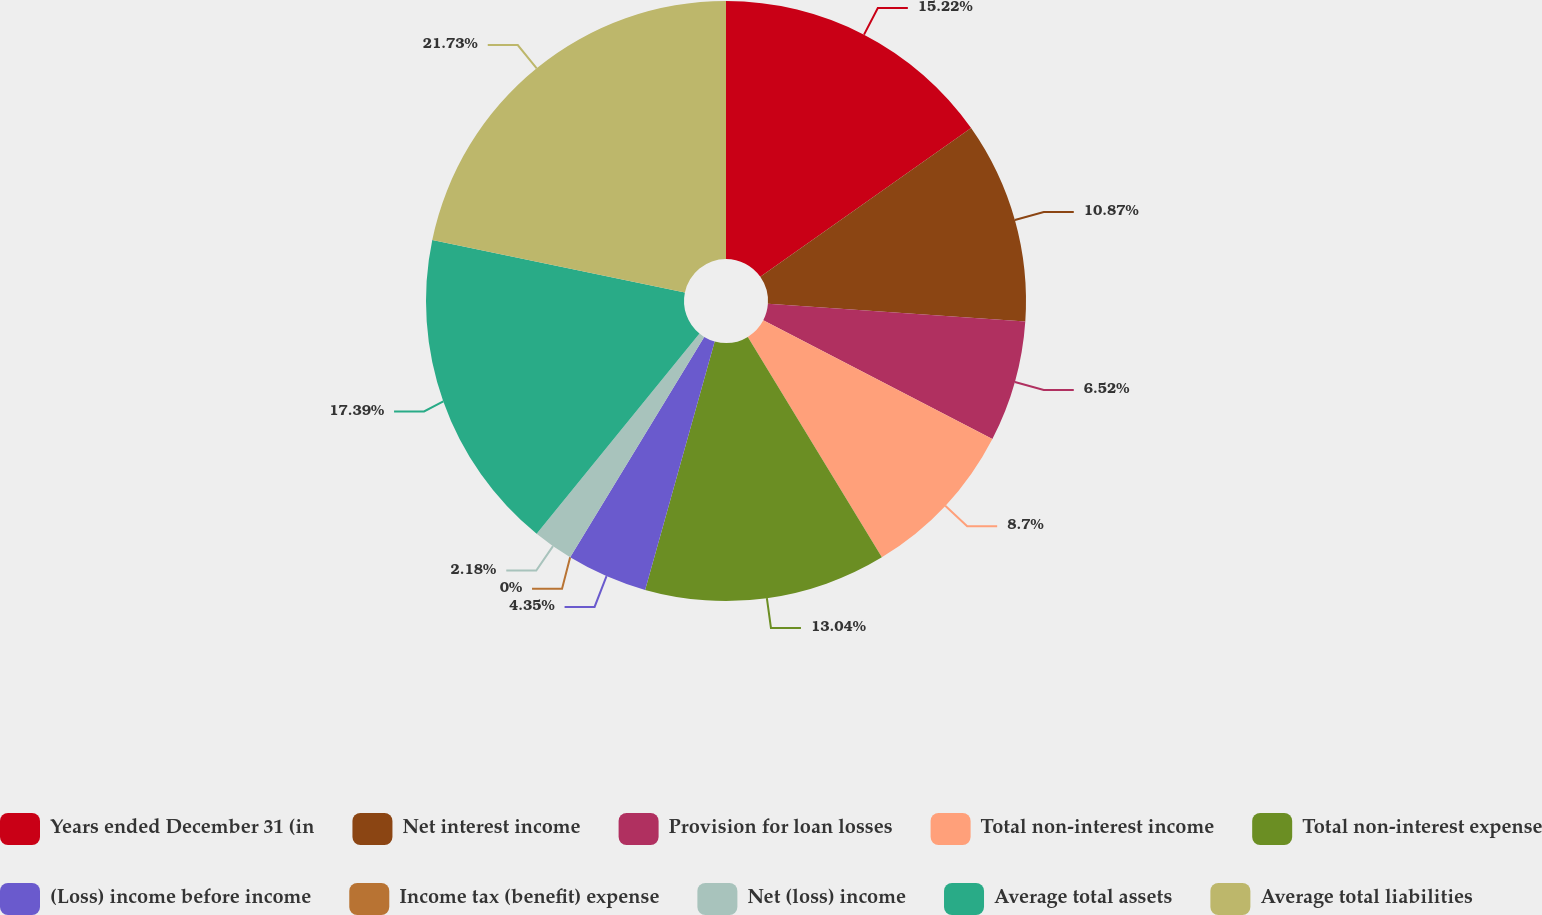Convert chart. <chart><loc_0><loc_0><loc_500><loc_500><pie_chart><fcel>Years ended December 31 (in<fcel>Net interest income<fcel>Provision for loan losses<fcel>Total non-interest income<fcel>Total non-interest expense<fcel>(Loss) income before income<fcel>Income tax (benefit) expense<fcel>Net (loss) income<fcel>Average total assets<fcel>Average total liabilities<nl><fcel>15.22%<fcel>10.87%<fcel>6.52%<fcel>8.7%<fcel>13.04%<fcel>4.35%<fcel>0.0%<fcel>2.18%<fcel>17.39%<fcel>21.74%<nl></chart> 